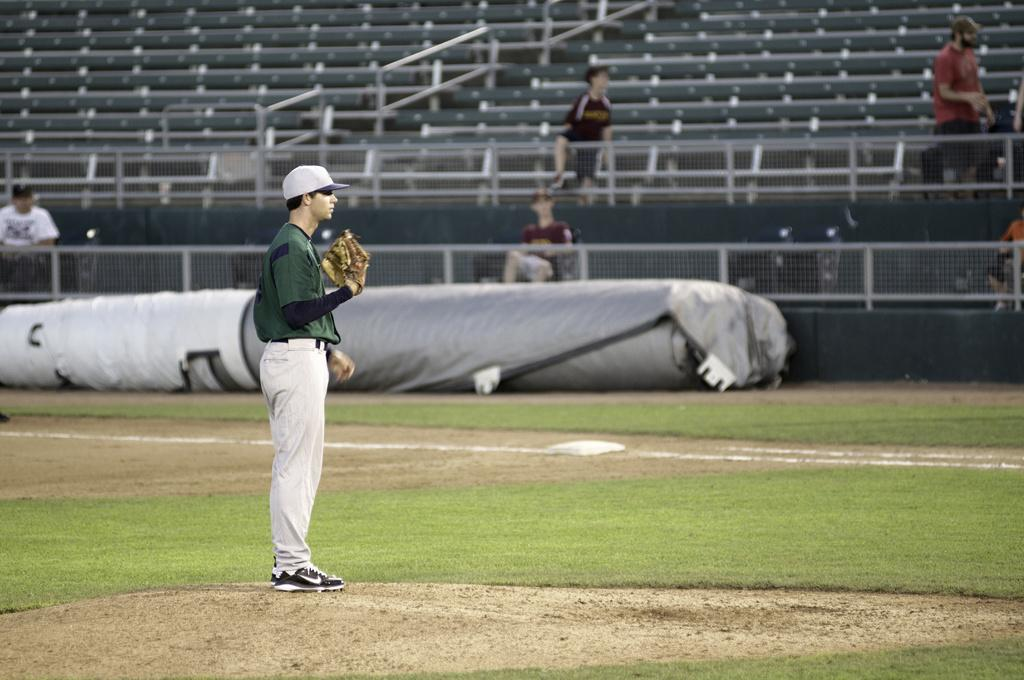How many people are in the image? There are people in the image, but the exact number is not specified. What are some of the people doing in the image? Some people are standing, and some are sitting on chairs. What can be seen in the background of the image? In the background of the image, there are chairs, a fence, grass, and other unspecified elements. What type of punishment is being administered to the person standing near the curtain in the image? There is no mention of a curtain or punishment in the image. The image only features people, chairs, a fence, and grass in the background. 